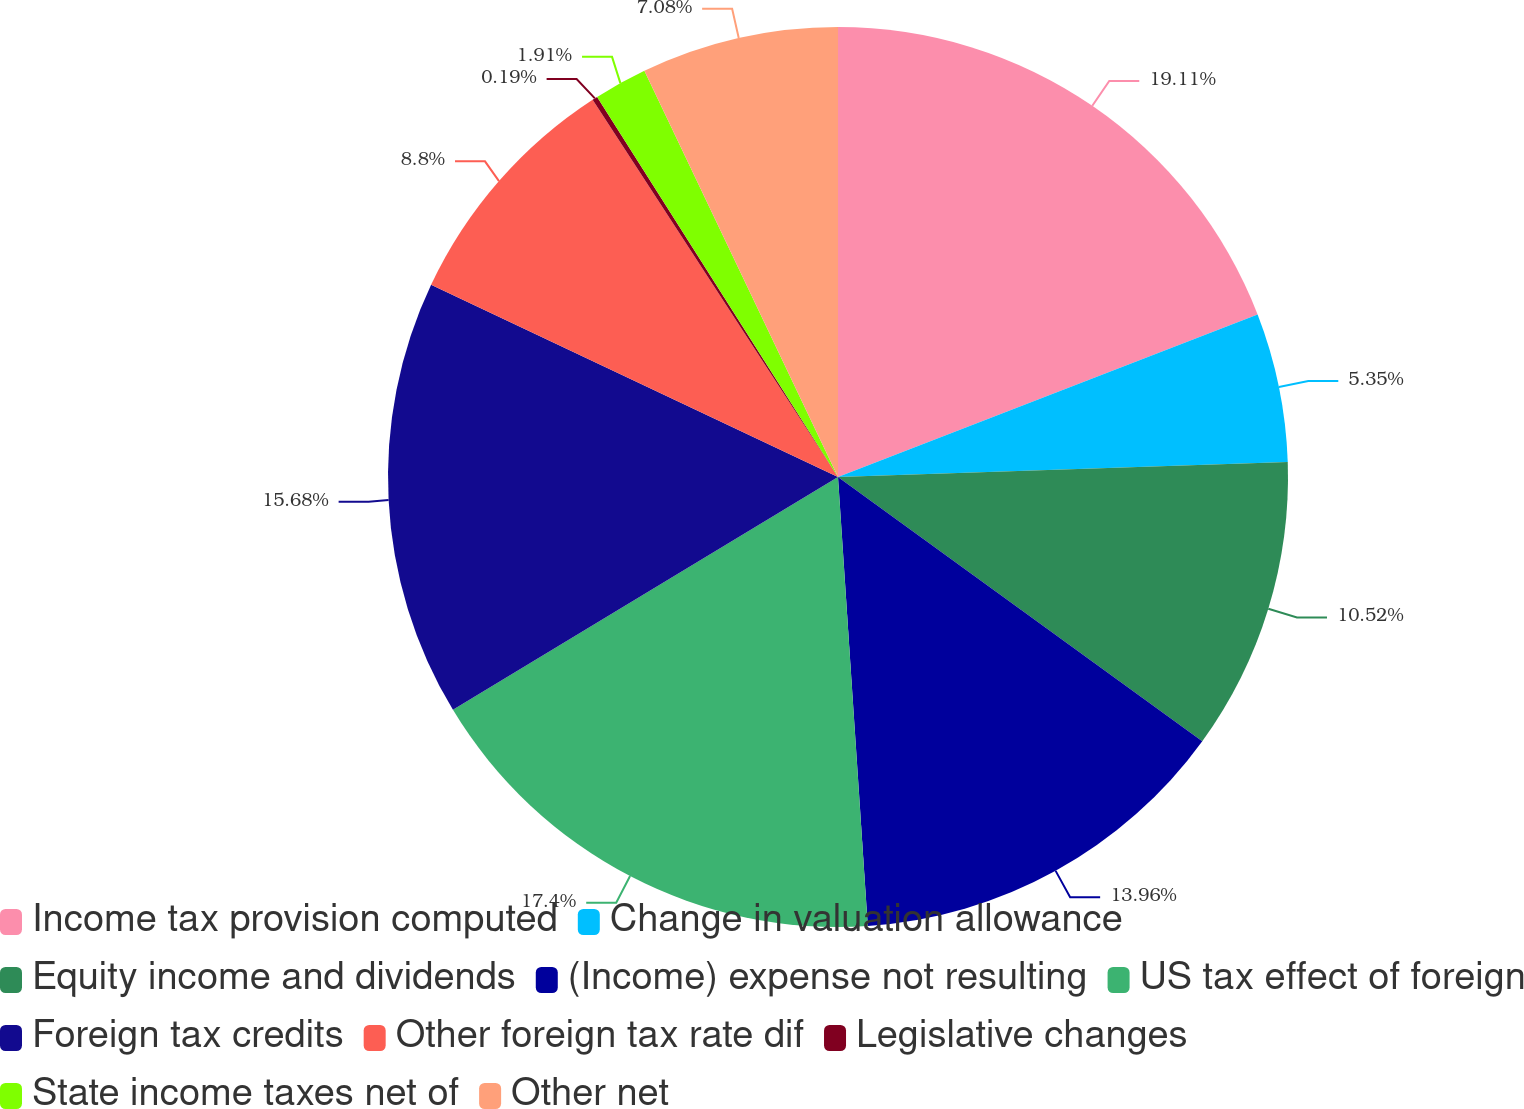Convert chart to OTSL. <chart><loc_0><loc_0><loc_500><loc_500><pie_chart><fcel>Income tax provision computed<fcel>Change in valuation allowance<fcel>Equity income and dividends<fcel>(Income) expense not resulting<fcel>US tax effect of foreign<fcel>Foreign tax credits<fcel>Other foreign tax rate dif<fcel>Legislative changes<fcel>State income taxes net of<fcel>Other net<nl><fcel>19.12%<fcel>5.35%<fcel>10.52%<fcel>13.96%<fcel>17.4%<fcel>15.68%<fcel>8.8%<fcel>0.19%<fcel>1.91%<fcel>7.08%<nl></chart> 